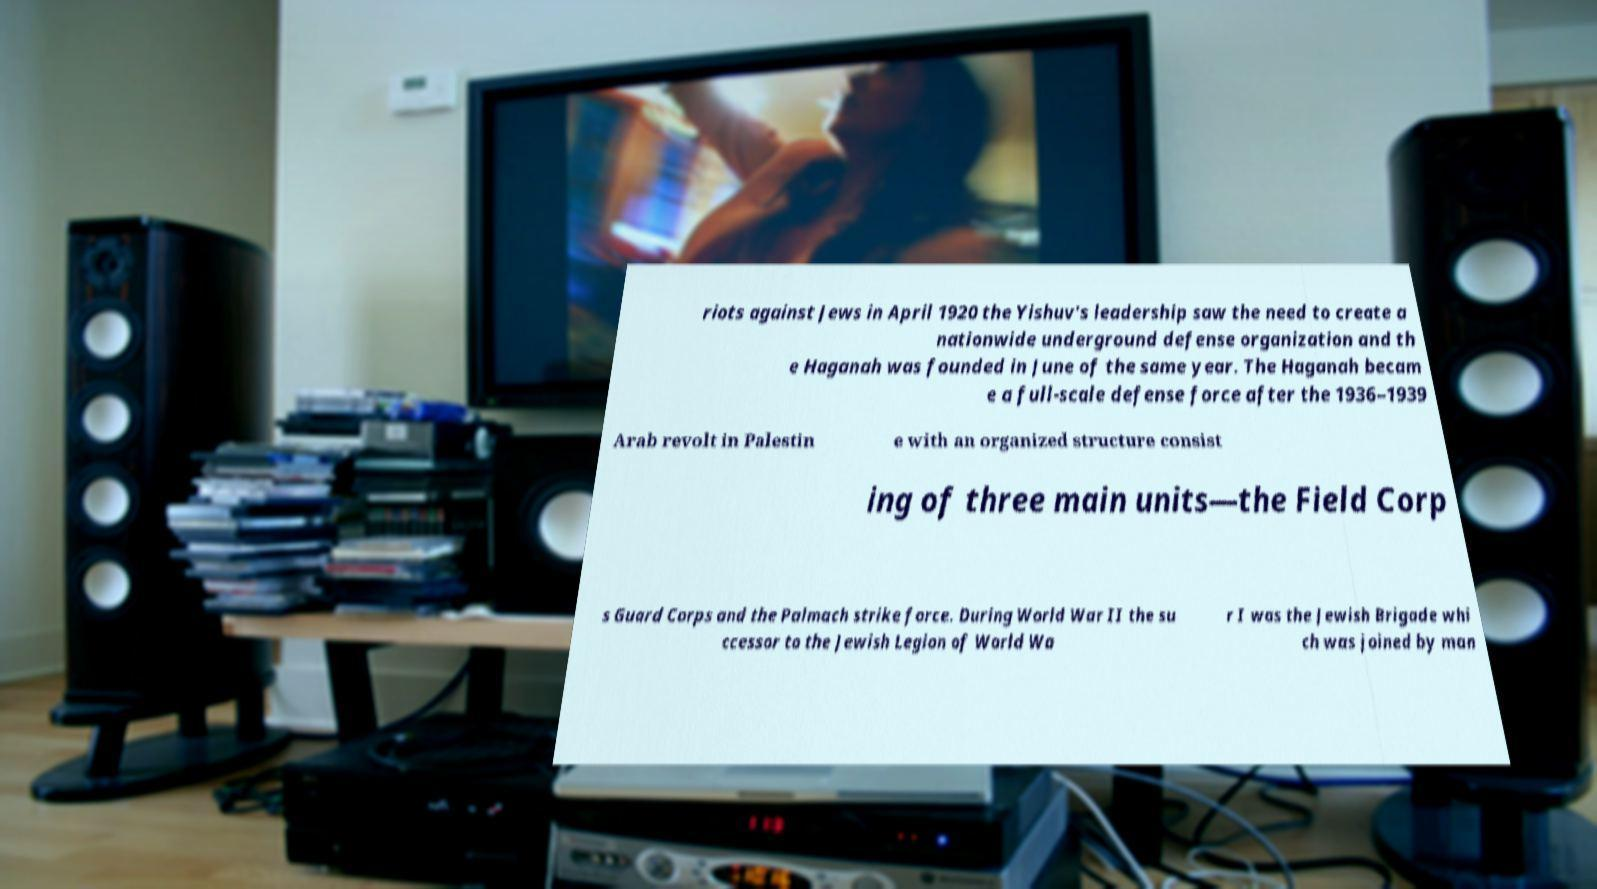What messages or text are displayed in this image? I need them in a readable, typed format. riots against Jews in April 1920 the Yishuv's leadership saw the need to create a nationwide underground defense organization and th e Haganah was founded in June of the same year. The Haganah becam e a full-scale defense force after the 1936–1939 Arab revolt in Palestin e with an organized structure consist ing of three main units—the Field Corp s Guard Corps and the Palmach strike force. During World War II the su ccessor to the Jewish Legion of World Wa r I was the Jewish Brigade whi ch was joined by man 